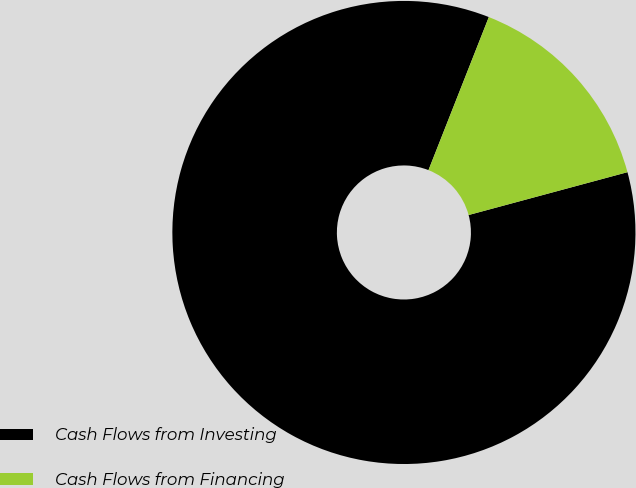Convert chart to OTSL. <chart><loc_0><loc_0><loc_500><loc_500><pie_chart><fcel>Cash Flows from Investing<fcel>Cash Flows from Financing<nl><fcel>85.17%<fcel>14.83%<nl></chart> 